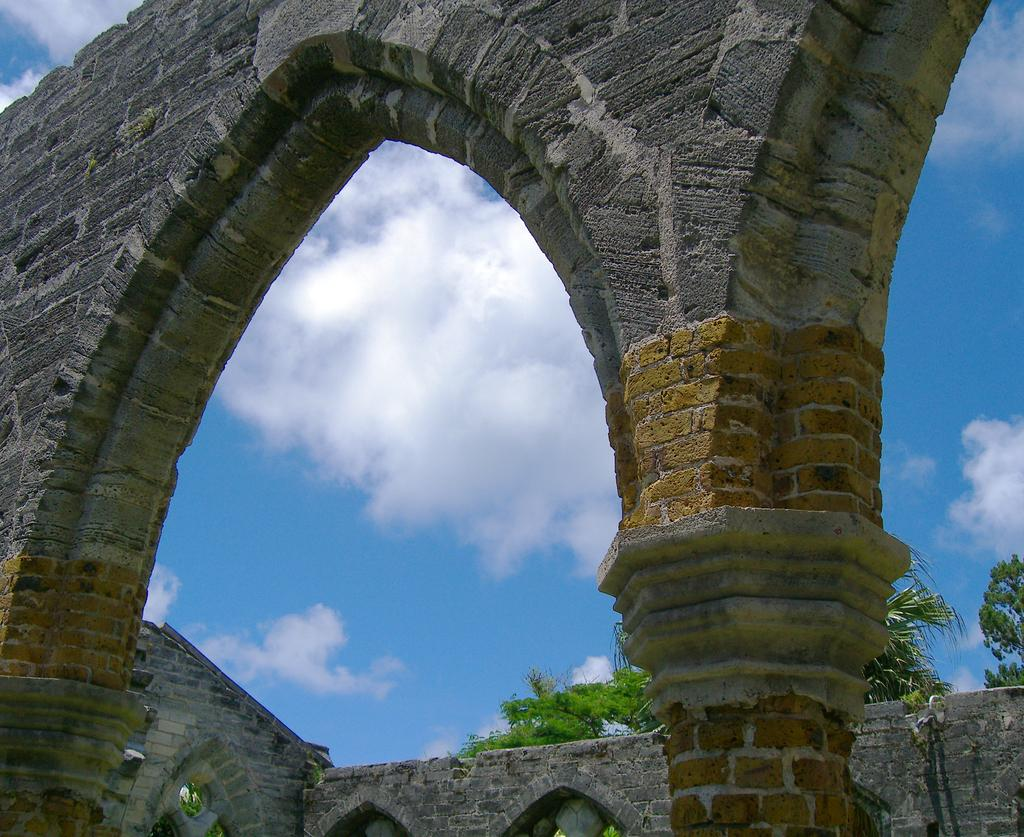What is visible at the top of the image? The sky is visible in the image. What can be seen in the sky? There are clouds in the sky. What type of structure is present in the image? There is a wall in the image. What architectural features are visible at the bottom of the image? There are pillars towards the bottom of the image. What type of vegetation is present in the image? There are trees in the image. What type of canvas is being used to paint the trees in the image? There is no canvas or painting present in the image; it is a photograph of real trees. How much credit is given to the architect who designed the pillars in the image? The image does not provide information about the architect or the credit given to them. 